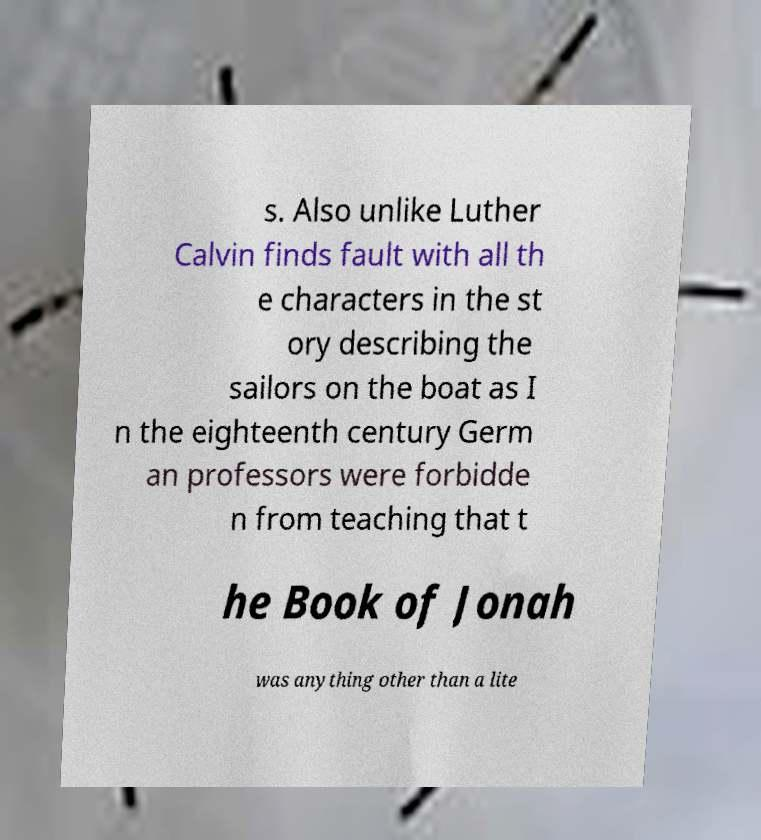For documentation purposes, I need the text within this image transcribed. Could you provide that? s. Also unlike Luther Calvin finds fault with all th e characters in the st ory describing the sailors on the boat as I n the eighteenth century Germ an professors were forbidde n from teaching that t he Book of Jonah was anything other than a lite 